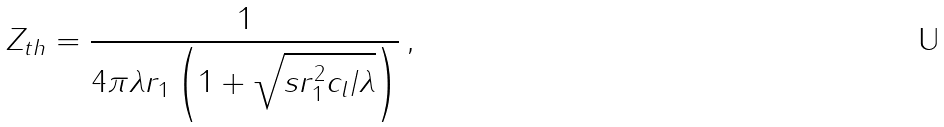Convert formula to latex. <formula><loc_0><loc_0><loc_500><loc_500>Z _ { t h } = \frac { 1 } { 4 \pi \lambda r _ { 1 } \left ( 1 + \sqrt { s r _ { 1 } ^ { 2 } c _ { l } / \lambda } \right ) } \, ,</formula> 